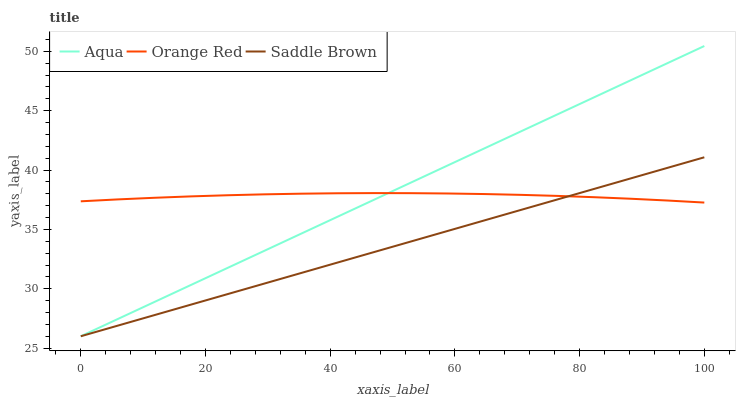Does Saddle Brown have the minimum area under the curve?
Answer yes or no. Yes. Does Aqua have the maximum area under the curve?
Answer yes or no. Yes. Does Orange Red have the minimum area under the curve?
Answer yes or no. No. Does Orange Red have the maximum area under the curve?
Answer yes or no. No. Is Saddle Brown the smoothest?
Answer yes or no. Yes. Is Orange Red the roughest?
Answer yes or no. Yes. Is Orange Red the smoothest?
Answer yes or no. No. Is Saddle Brown the roughest?
Answer yes or no. No. Does Aqua have the lowest value?
Answer yes or no. Yes. Does Orange Red have the lowest value?
Answer yes or no. No. Does Aqua have the highest value?
Answer yes or no. Yes. Does Saddle Brown have the highest value?
Answer yes or no. No. Does Aqua intersect Orange Red?
Answer yes or no. Yes. Is Aqua less than Orange Red?
Answer yes or no. No. Is Aqua greater than Orange Red?
Answer yes or no. No. 